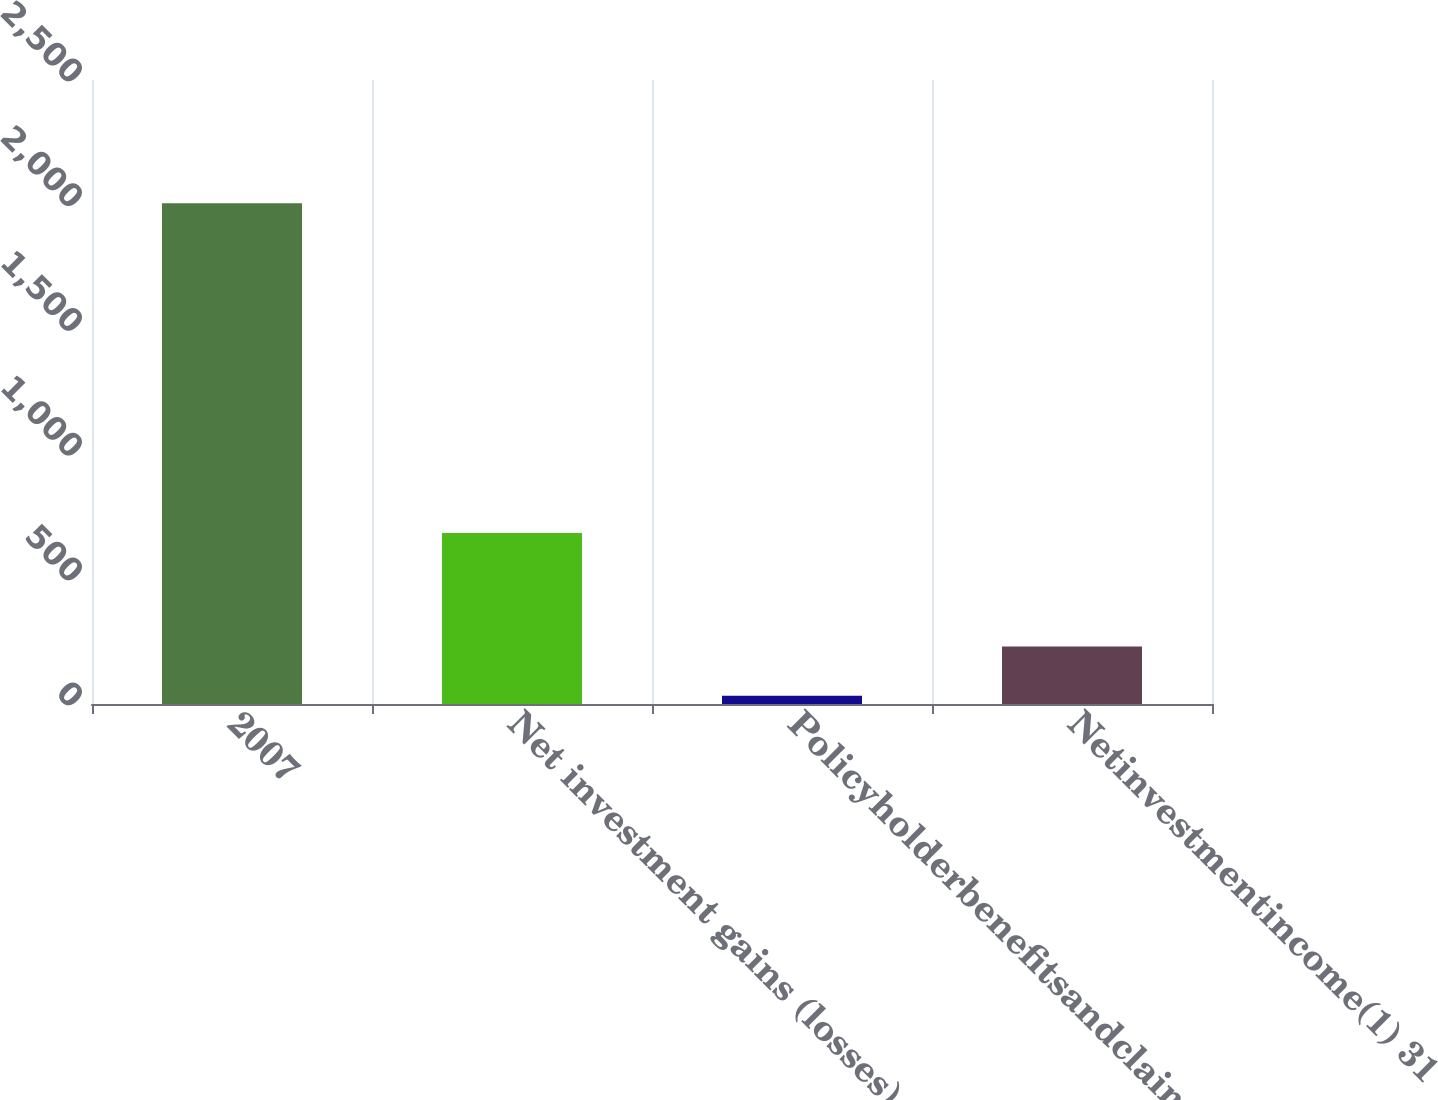Convert chart to OTSL. <chart><loc_0><loc_0><loc_500><loc_500><bar_chart><fcel>2007<fcel>Net investment gains (losses)<fcel>Policyholderbenefitsandclaims<fcel>Netinvestmentincome(1) 31<nl><fcel>2006<fcel>685<fcel>33<fcel>230.3<nl></chart> 